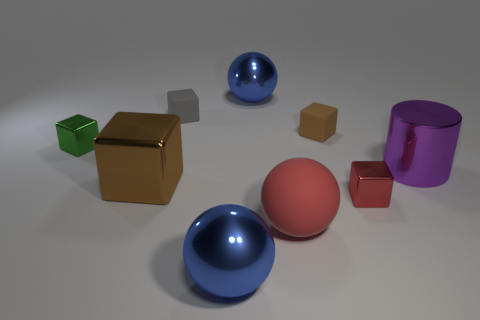Does the purple thing have the same material as the block that is behind the small brown cube?
Provide a short and direct response. No. Is there any other thing that has the same shape as the gray matte thing?
Make the answer very short. Yes. What is the color of the cube that is right of the tiny gray matte cube and in front of the tiny green block?
Keep it short and to the point. Red. There is a large blue metallic thing that is behind the small red shiny object; what is its shape?
Your answer should be compact. Sphere. What is the size of the blue thing that is behind the tiny shiny block that is to the right of the matte object in front of the tiny green object?
Your answer should be compact. Large. There is a large blue ball that is behind the green thing; what number of brown matte objects are to the left of it?
Provide a succinct answer. 0. There is a metal thing that is behind the large brown block and in front of the green metal thing; what size is it?
Give a very brief answer. Large. What number of metal objects are either tiny red things or large blue spheres?
Ensure brevity in your answer.  3. What material is the large block?
Give a very brief answer. Metal. There is a brown block to the right of the large blue sphere behind the blue object in front of the gray block; what is its material?
Your answer should be very brief. Rubber. 